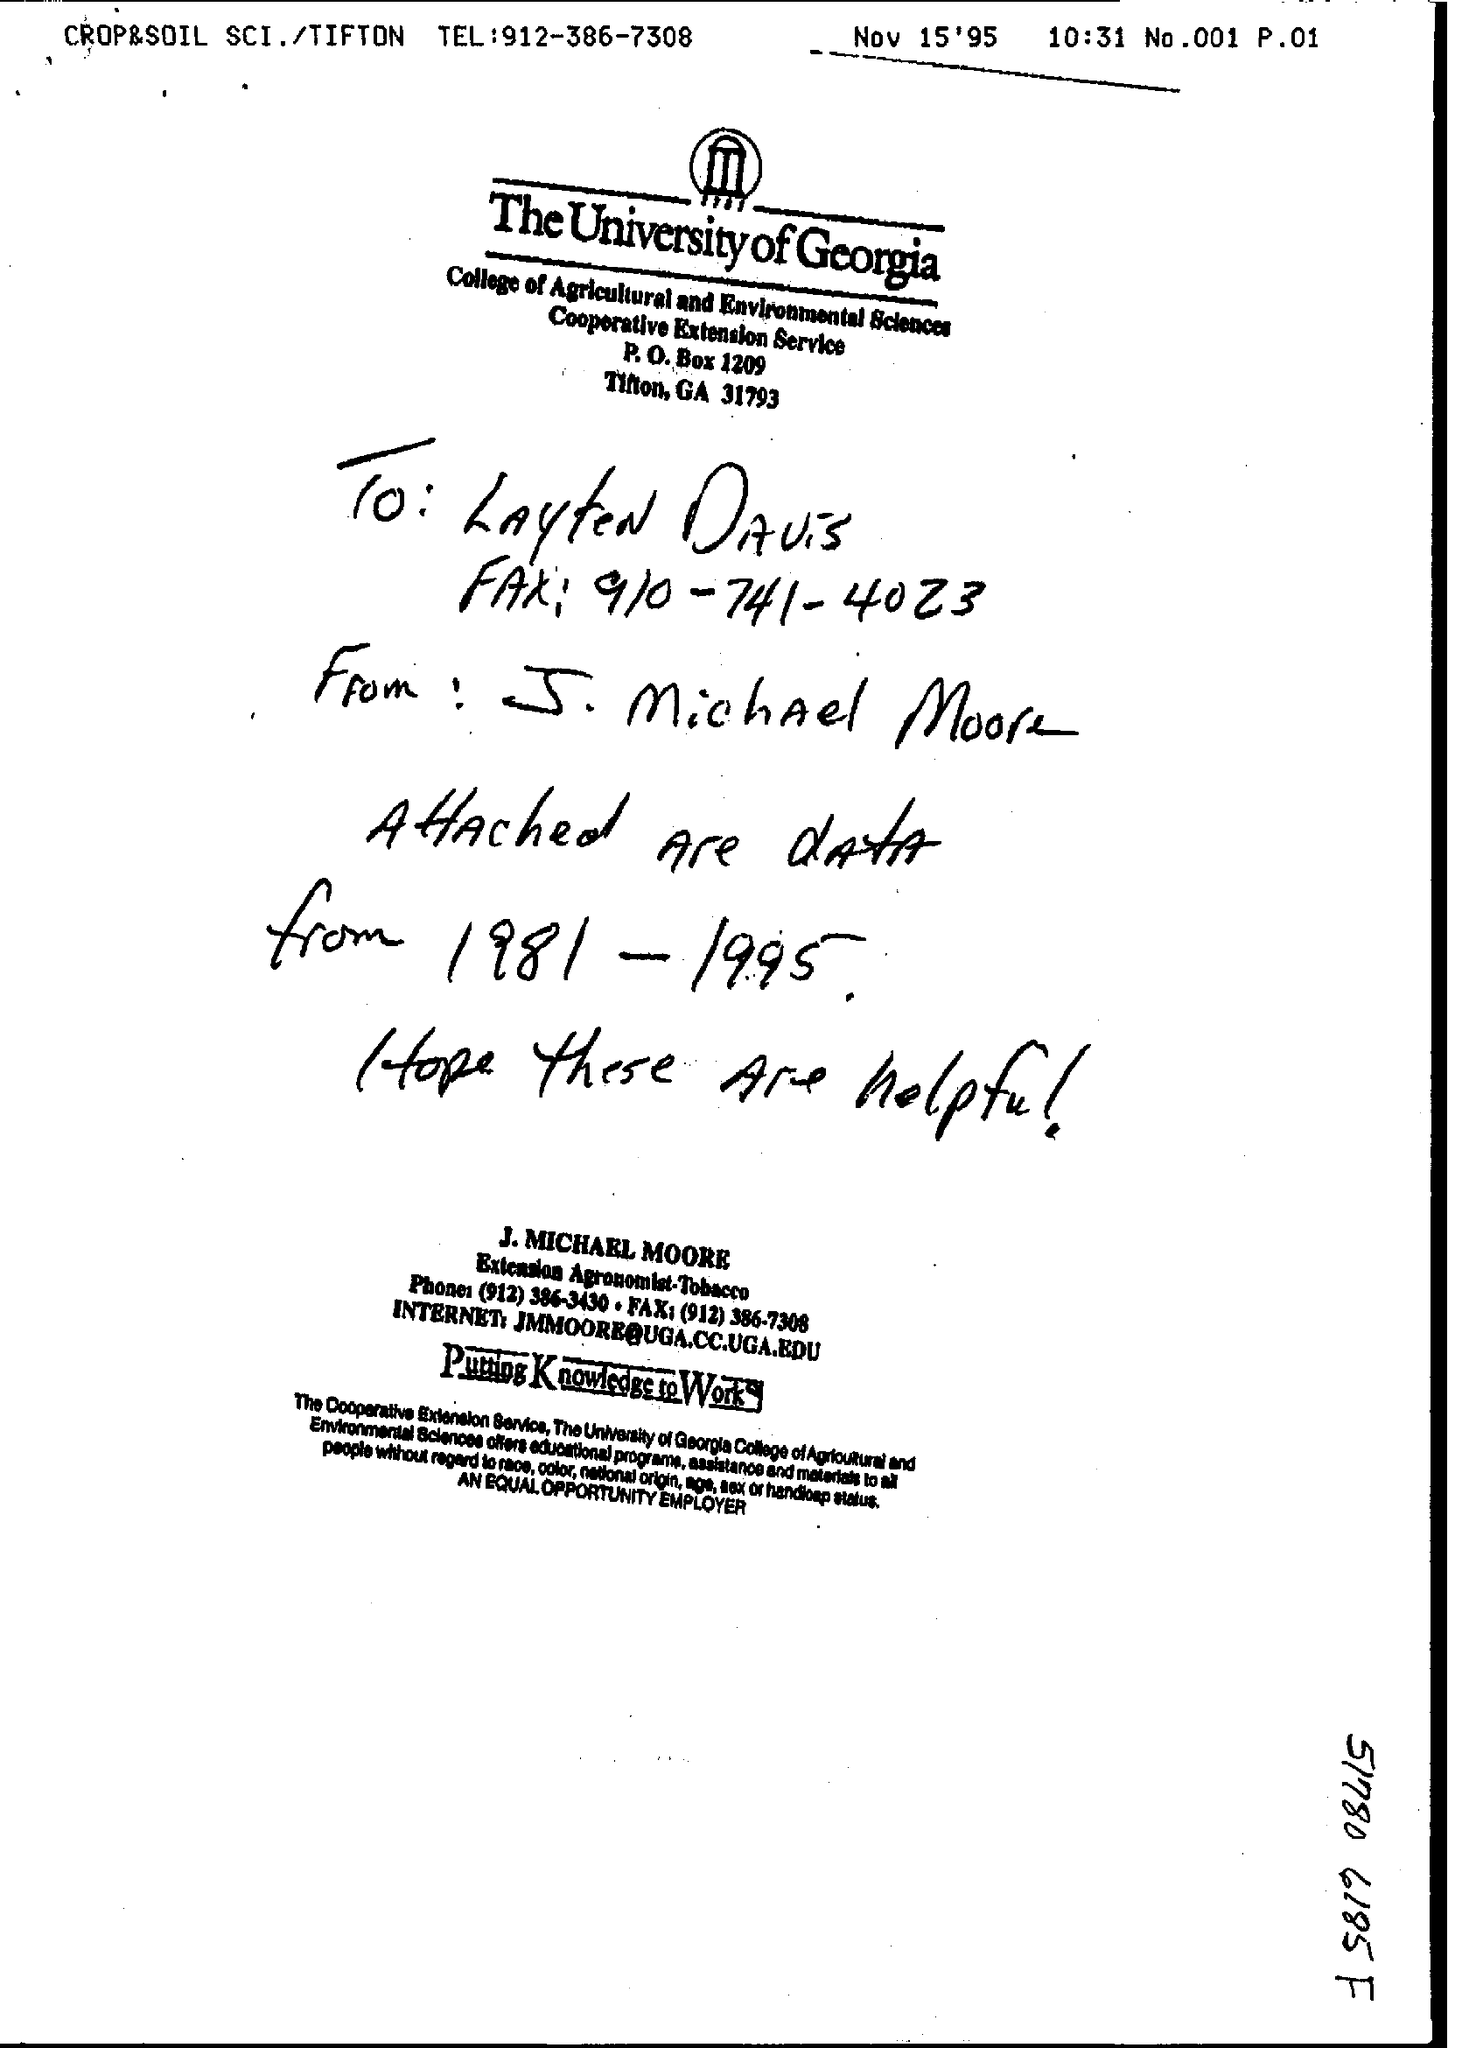Who is the note addressed to?
Make the answer very short. Layten Davis. What is the phone number given?
Your answer should be very brief. (912) 386-3430. 